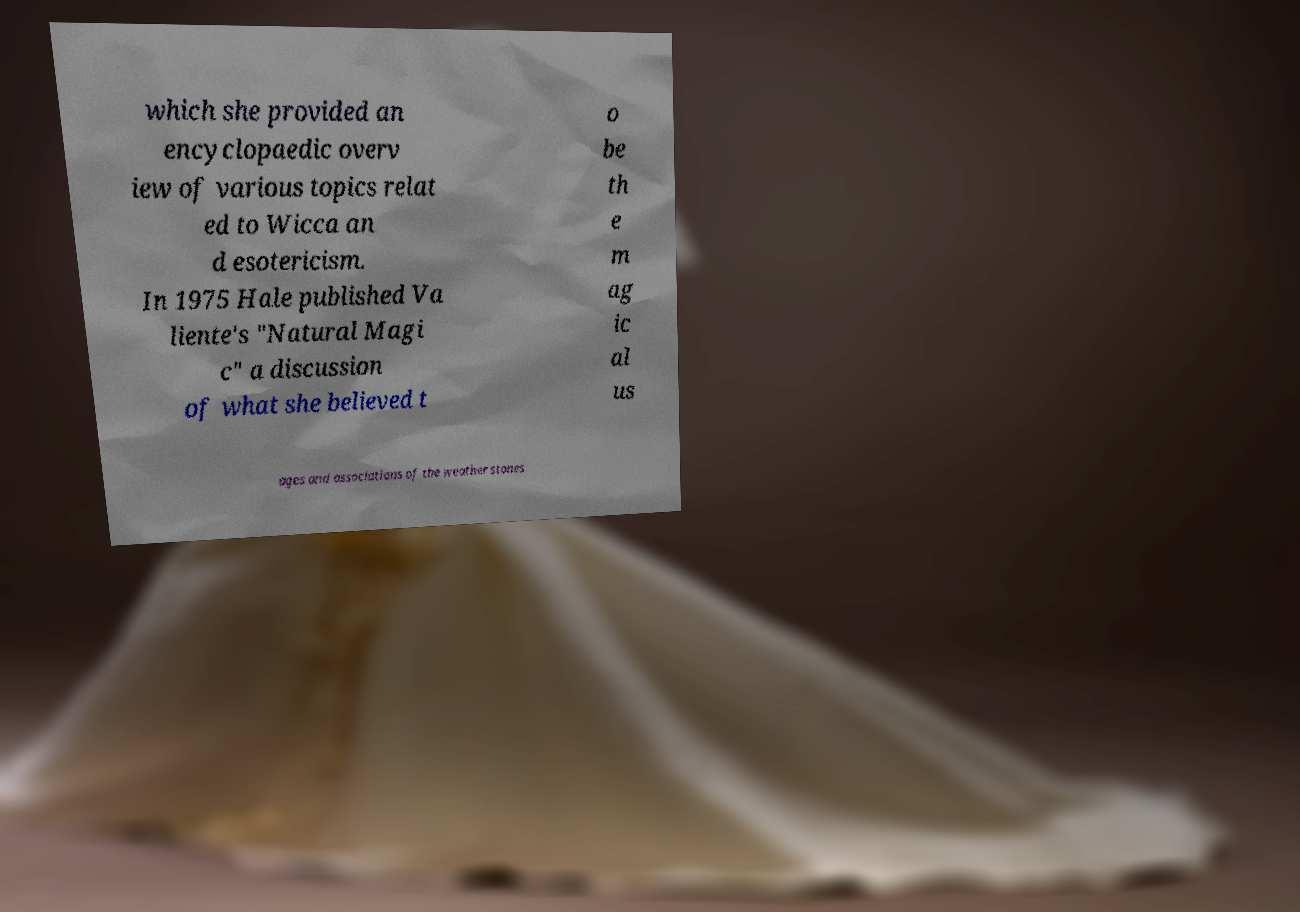Could you extract and type out the text from this image? which she provided an encyclopaedic overv iew of various topics relat ed to Wicca an d esotericism. In 1975 Hale published Va liente's "Natural Magi c" a discussion of what she believed t o be th e m ag ic al us ages and associations of the weather stones 